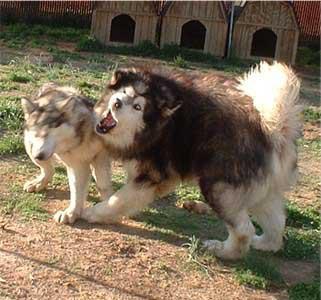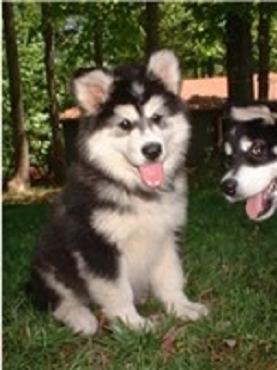The first image is the image on the left, the second image is the image on the right. Given the left and right images, does the statement "There are exactly two dogs in total." hold true? Answer yes or no. No. The first image is the image on the left, the second image is the image on the right. Evaluate the accuracy of this statement regarding the images: "There are exactly two dogs and two people.". Is it true? Answer yes or no. No. 